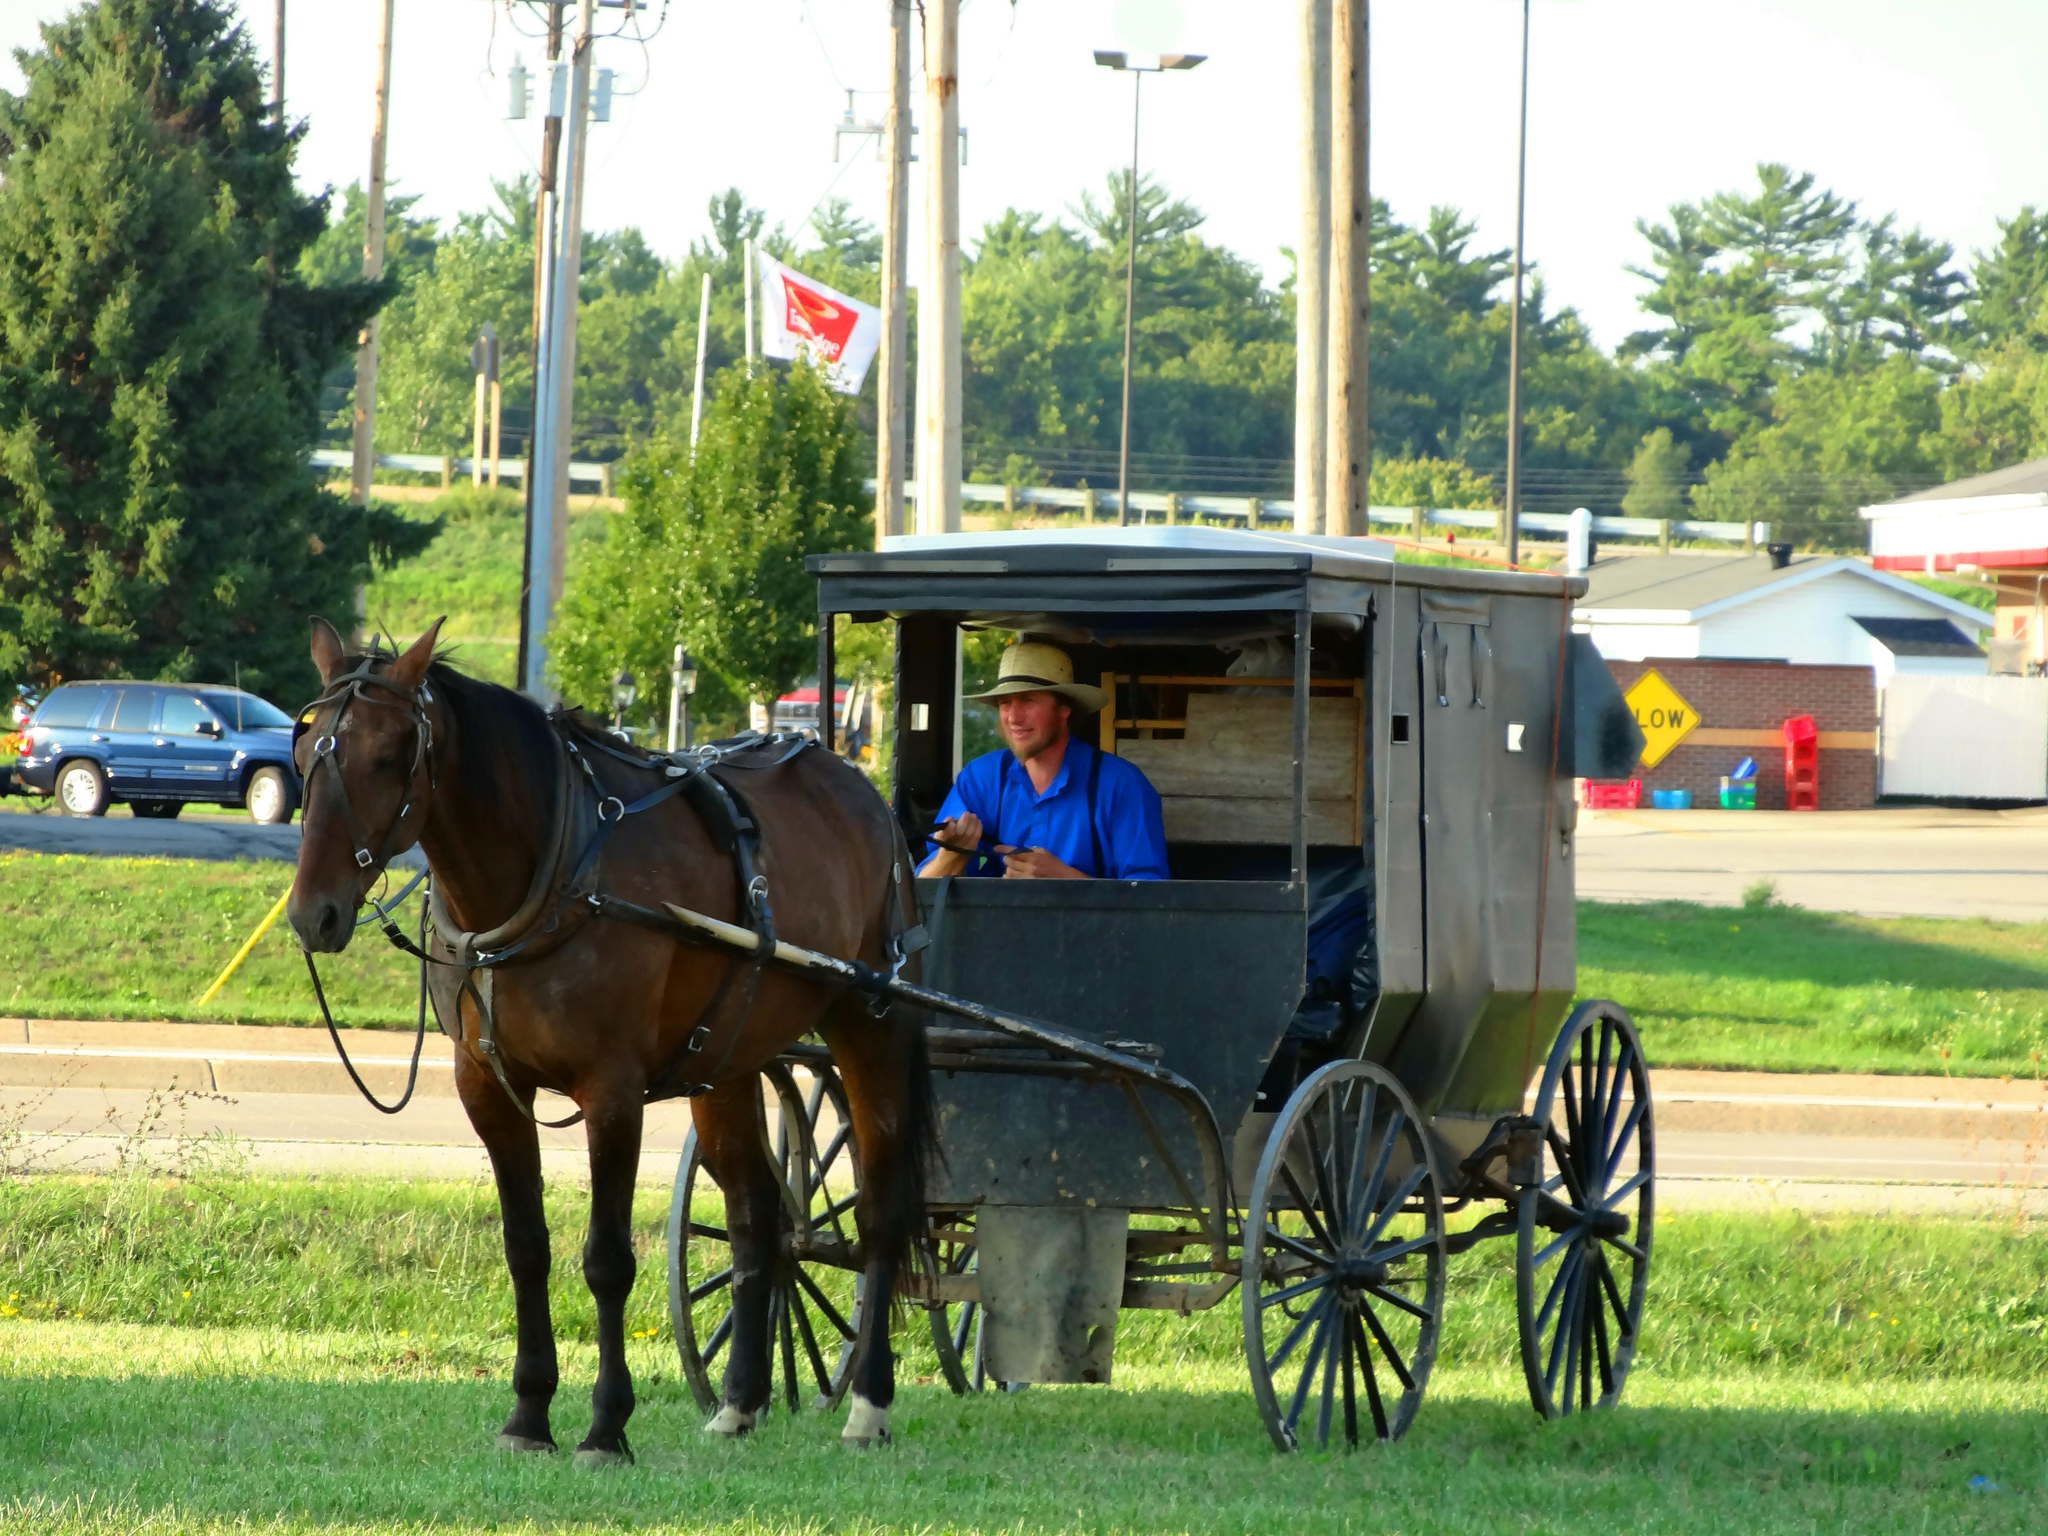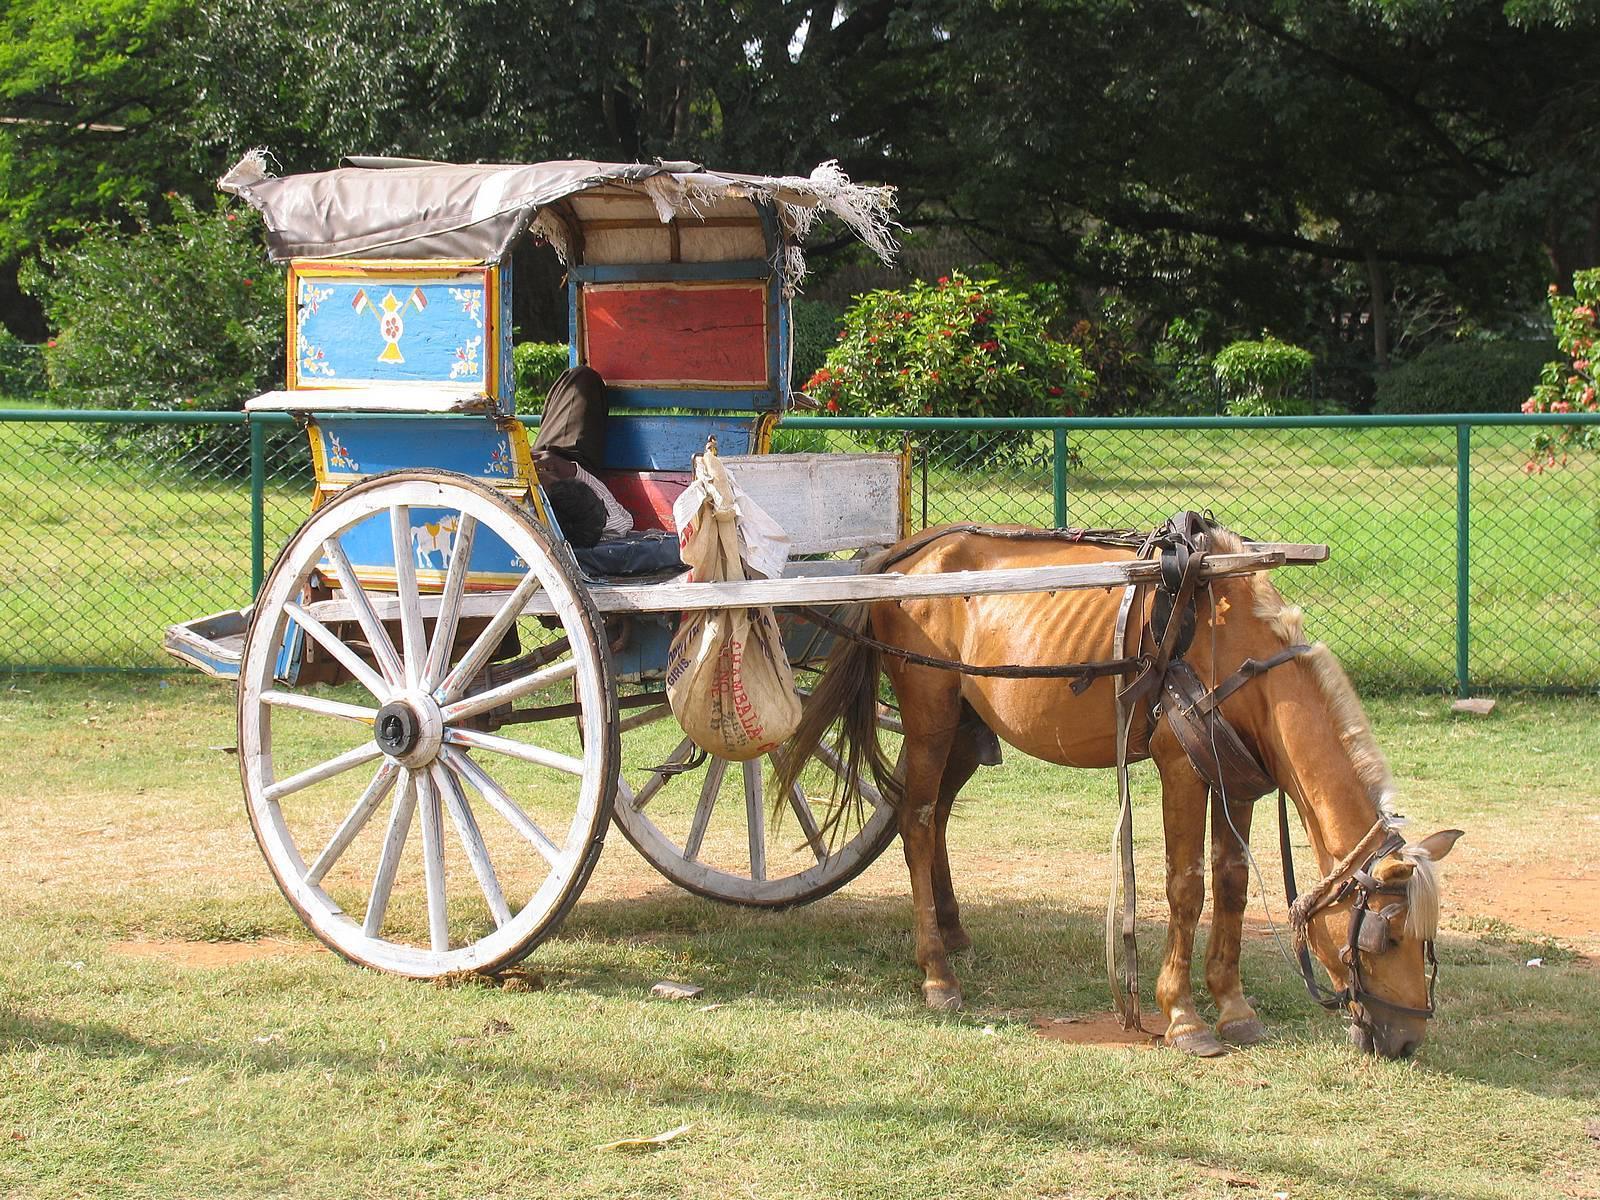The first image is the image on the left, the second image is the image on the right. Considering the images on both sides, is "Both of the carts are covered." valid? Answer yes or no. Yes. 